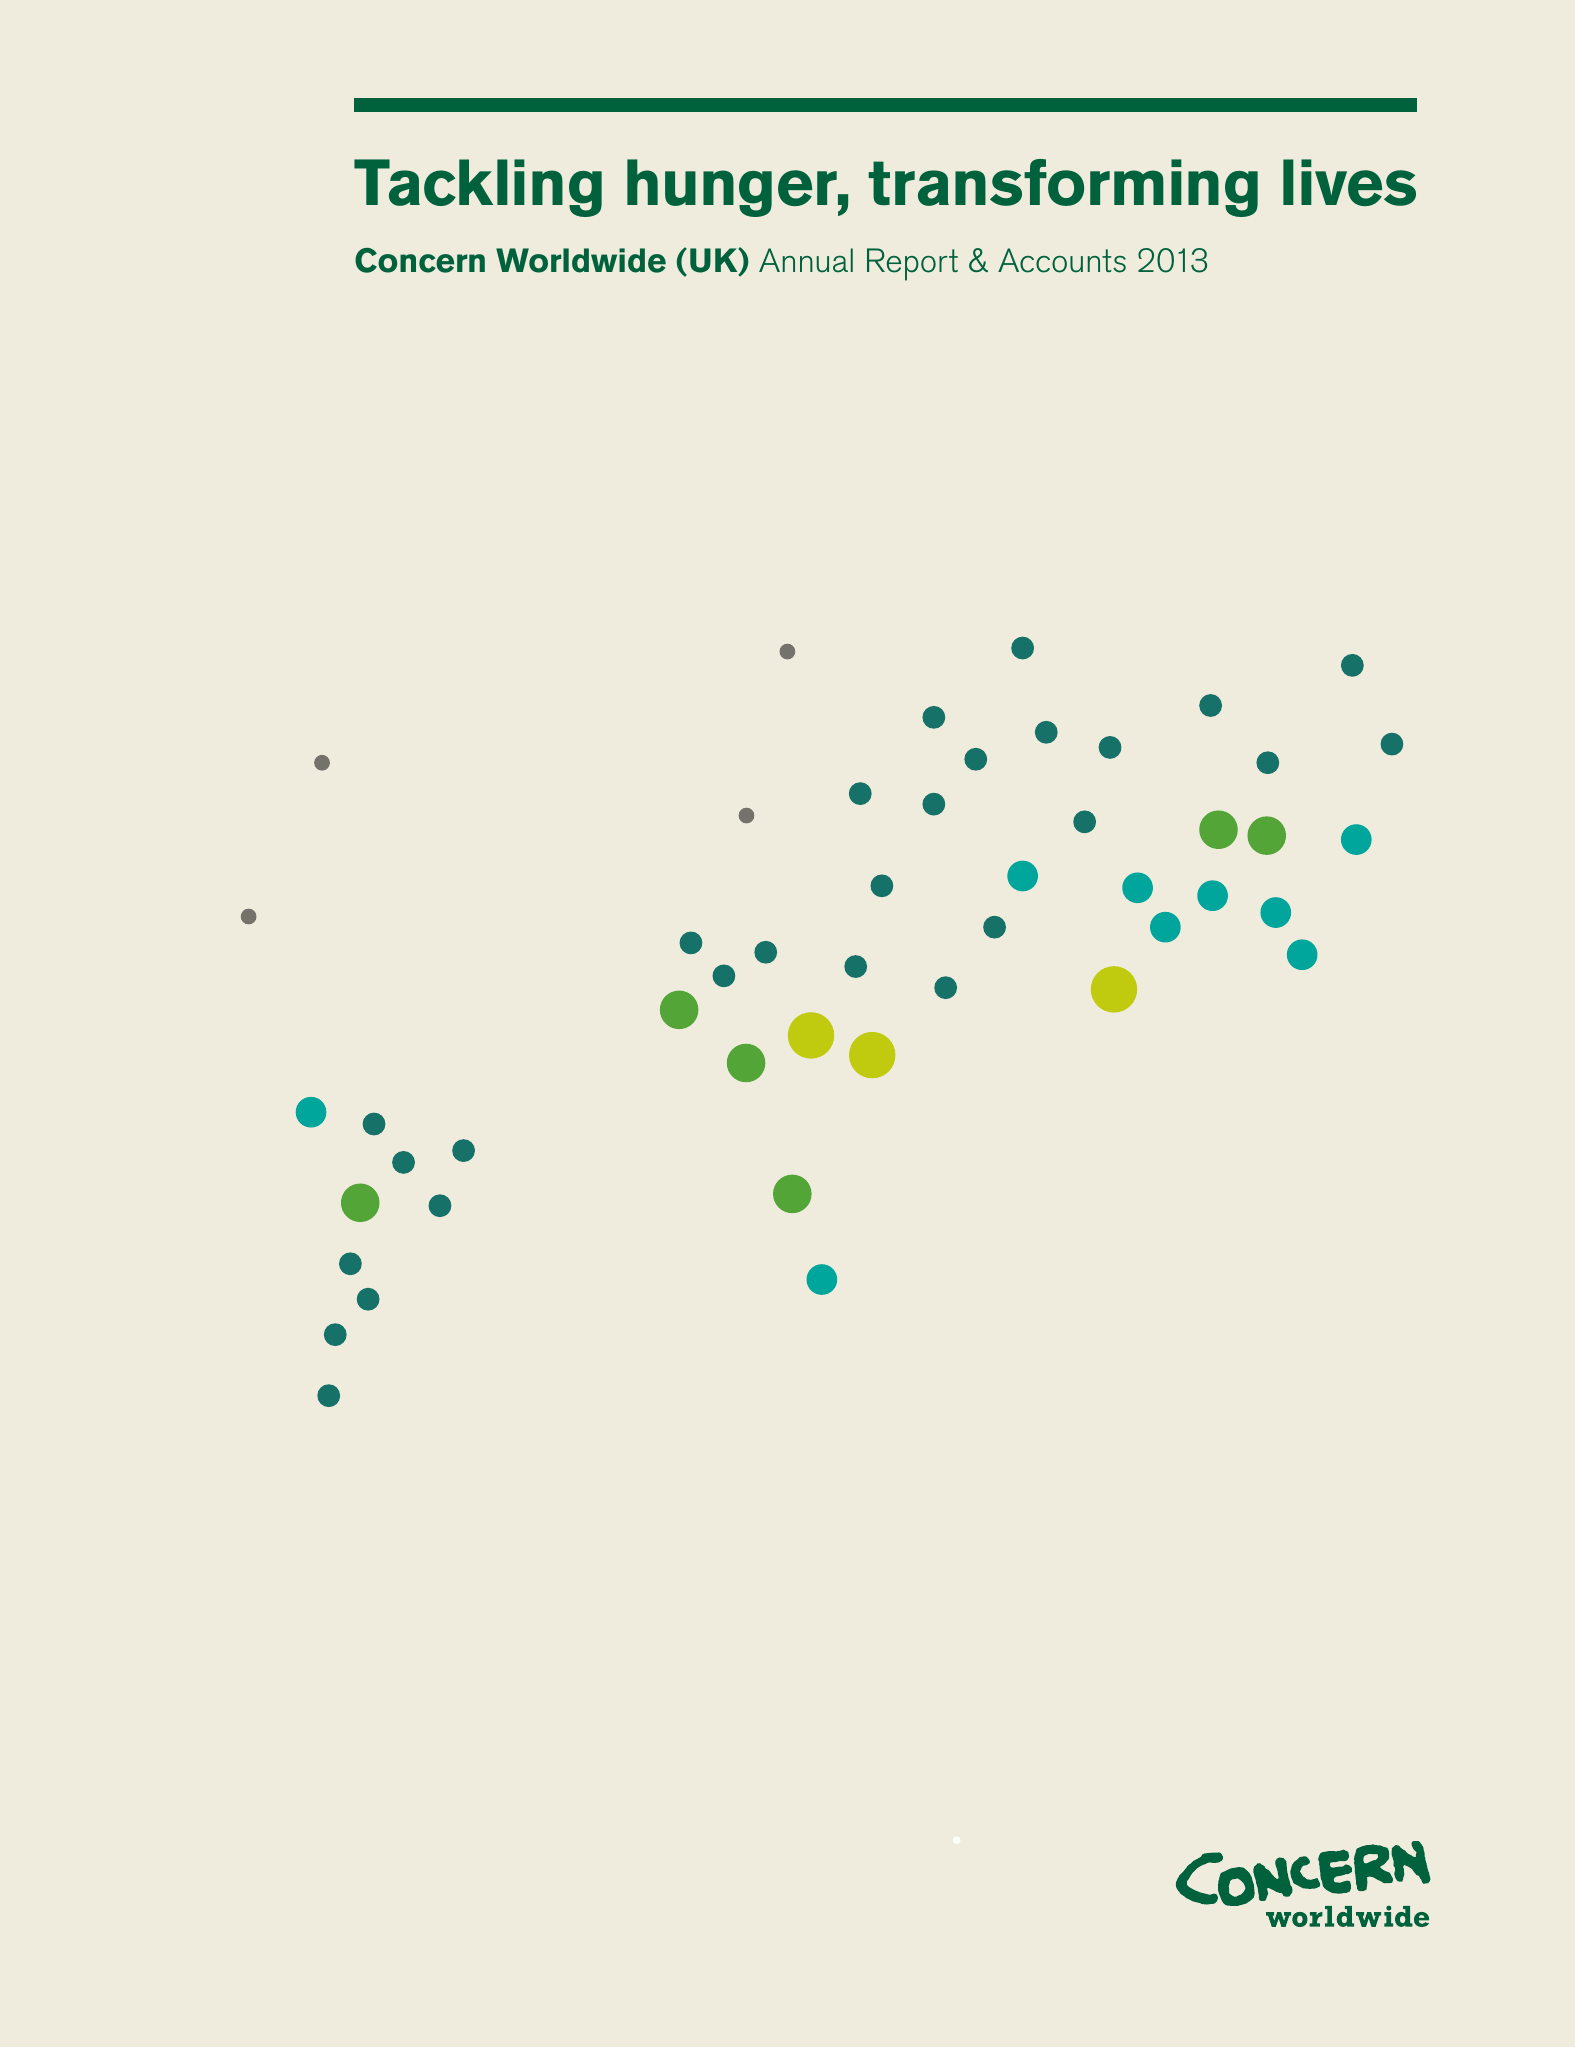What is the value for the income_annually_in_british_pounds?
Answer the question using a single word or phrase. 17839839.00 